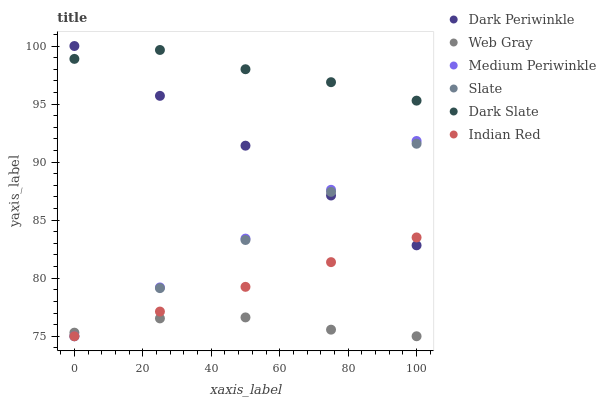Does Web Gray have the minimum area under the curve?
Answer yes or no. Yes. Does Dark Slate have the maximum area under the curve?
Answer yes or no. Yes. Does Slate have the minimum area under the curve?
Answer yes or no. No. Does Slate have the maximum area under the curve?
Answer yes or no. No. Is Dark Periwinkle the smoothest?
Answer yes or no. Yes. Is Dark Slate the roughest?
Answer yes or no. Yes. Is Slate the smoothest?
Answer yes or no. No. Is Slate the roughest?
Answer yes or no. No. Does Web Gray have the lowest value?
Answer yes or no. Yes. Does Dark Slate have the lowest value?
Answer yes or no. No. Does Dark Periwinkle have the highest value?
Answer yes or no. Yes. Does Slate have the highest value?
Answer yes or no. No. Is Indian Red less than Dark Slate?
Answer yes or no. Yes. Is Dark Slate greater than Web Gray?
Answer yes or no. Yes. Does Indian Red intersect Dark Periwinkle?
Answer yes or no. Yes. Is Indian Red less than Dark Periwinkle?
Answer yes or no. No. Is Indian Red greater than Dark Periwinkle?
Answer yes or no. No. Does Indian Red intersect Dark Slate?
Answer yes or no. No. 